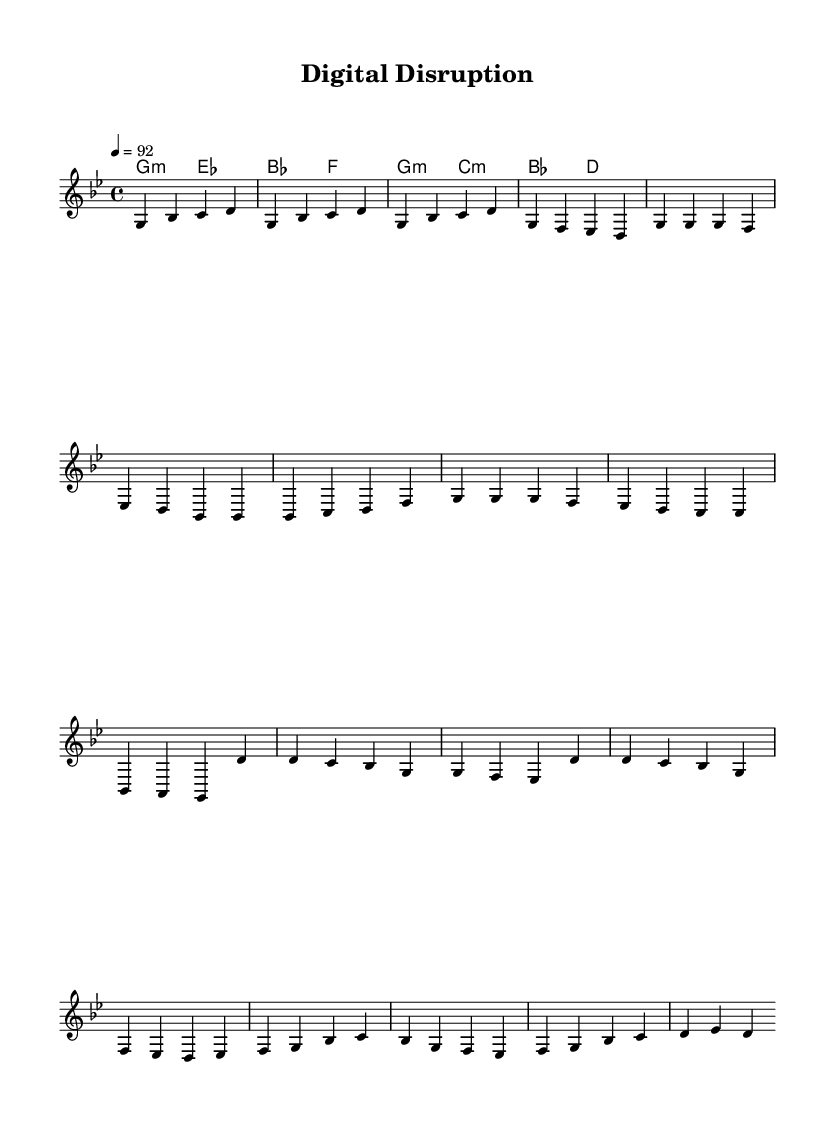What is the key signature of this music? The key signature appears to be G minor, which has two flats (B♭ and E♭) indicated in the beginning and corresponds to the notes in the melody and harmonies.
Answer: G minor What is the time signature of this music? The time signature is visible at the beginning of the sheet music, indicated as 4/4, which means there are four beats in each measure and the quarter note receives one beat.
Answer: 4/4 What is the tempo marking for this piece? The tempo marking is found in the measure at the beginning, indicated by the notation "4 = 92," meaning there are 92 beats per minute with a quarter note duration counting as one beat.
Answer: 92 How many measures are in the verse? The verse consists of eight measures, as counted from the beginning of the verse section to the end. Each measure is separated by a vertical line, and the total can be tallied as eight measures altogether.
Answer: 8 What chord follows the G minor chord at the beginning? The first chord after G minor is E♭ major, as indicated in the chord progression where the second measure shows a shift from G minor to E♭ major.
Answer: E♭ major What is the primary theme reflected in this hip-hop piece's melody? The melody of this hip-hop piece explores themes of digital disruption and technology's impact on society, as indicated by the title "Digital Disruption" and the structure of the lyrics that might accompany the music.
Answer: Digital disruption 